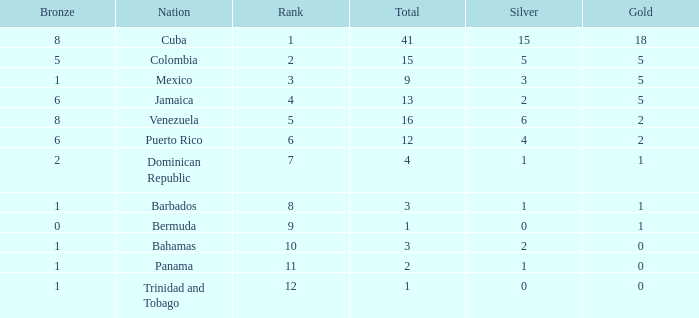Which Bronze is the highest one that has a Rank larger than 1, and a Nation of dominican republic, and a Total larger than 4? None. 